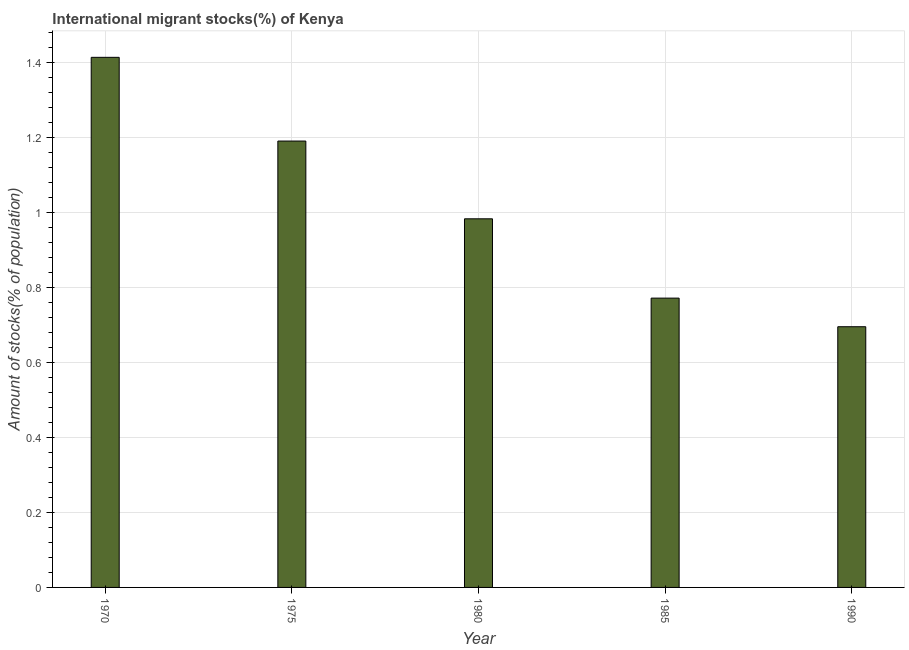Does the graph contain any zero values?
Make the answer very short. No. Does the graph contain grids?
Your response must be concise. Yes. What is the title of the graph?
Provide a short and direct response. International migrant stocks(%) of Kenya. What is the label or title of the Y-axis?
Offer a very short reply. Amount of stocks(% of population). What is the number of international migrant stocks in 1980?
Ensure brevity in your answer.  0.98. Across all years, what is the maximum number of international migrant stocks?
Your answer should be very brief. 1.41. Across all years, what is the minimum number of international migrant stocks?
Your answer should be compact. 0.7. What is the sum of the number of international migrant stocks?
Offer a terse response. 5.05. What is the difference between the number of international migrant stocks in 1970 and 1985?
Offer a terse response. 0.64. What is the median number of international migrant stocks?
Offer a very short reply. 0.98. In how many years, is the number of international migrant stocks greater than 1.44 %?
Provide a short and direct response. 0. What is the ratio of the number of international migrant stocks in 1985 to that in 1990?
Provide a succinct answer. 1.11. What is the difference between the highest and the second highest number of international migrant stocks?
Offer a very short reply. 0.22. What is the difference between the highest and the lowest number of international migrant stocks?
Ensure brevity in your answer.  0.72. In how many years, is the number of international migrant stocks greater than the average number of international migrant stocks taken over all years?
Provide a succinct answer. 2. How many bars are there?
Provide a short and direct response. 5. Are all the bars in the graph horizontal?
Your answer should be compact. No. What is the difference between two consecutive major ticks on the Y-axis?
Your response must be concise. 0.2. What is the Amount of stocks(% of population) in 1970?
Your response must be concise. 1.41. What is the Amount of stocks(% of population) of 1975?
Your answer should be compact. 1.19. What is the Amount of stocks(% of population) of 1980?
Your answer should be compact. 0.98. What is the Amount of stocks(% of population) in 1985?
Offer a very short reply. 0.77. What is the Amount of stocks(% of population) in 1990?
Keep it short and to the point. 0.7. What is the difference between the Amount of stocks(% of population) in 1970 and 1975?
Make the answer very short. 0.22. What is the difference between the Amount of stocks(% of population) in 1970 and 1980?
Provide a succinct answer. 0.43. What is the difference between the Amount of stocks(% of population) in 1970 and 1985?
Provide a short and direct response. 0.64. What is the difference between the Amount of stocks(% of population) in 1970 and 1990?
Offer a terse response. 0.72. What is the difference between the Amount of stocks(% of population) in 1975 and 1980?
Your answer should be very brief. 0.21. What is the difference between the Amount of stocks(% of population) in 1975 and 1985?
Give a very brief answer. 0.42. What is the difference between the Amount of stocks(% of population) in 1975 and 1990?
Your response must be concise. 0.5. What is the difference between the Amount of stocks(% of population) in 1980 and 1985?
Provide a short and direct response. 0.21. What is the difference between the Amount of stocks(% of population) in 1980 and 1990?
Keep it short and to the point. 0.29. What is the difference between the Amount of stocks(% of population) in 1985 and 1990?
Keep it short and to the point. 0.08. What is the ratio of the Amount of stocks(% of population) in 1970 to that in 1975?
Offer a very short reply. 1.19. What is the ratio of the Amount of stocks(% of population) in 1970 to that in 1980?
Your response must be concise. 1.44. What is the ratio of the Amount of stocks(% of population) in 1970 to that in 1985?
Offer a very short reply. 1.83. What is the ratio of the Amount of stocks(% of population) in 1970 to that in 1990?
Your answer should be compact. 2.03. What is the ratio of the Amount of stocks(% of population) in 1975 to that in 1980?
Provide a short and direct response. 1.21. What is the ratio of the Amount of stocks(% of population) in 1975 to that in 1985?
Offer a very short reply. 1.54. What is the ratio of the Amount of stocks(% of population) in 1975 to that in 1990?
Ensure brevity in your answer.  1.71. What is the ratio of the Amount of stocks(% of population) in 1980 to that in 1985?
Your answer should be compact. 1.27. What is the ratio of the Amount of stocks(% of population) in 1980 to that in 1990?
Ensure brevity in your answer.  1.41. What is the ratio of the Amount of stocks(% of population) in 1985 to that in 1990?
Your answer should be very brief. 1.11. 